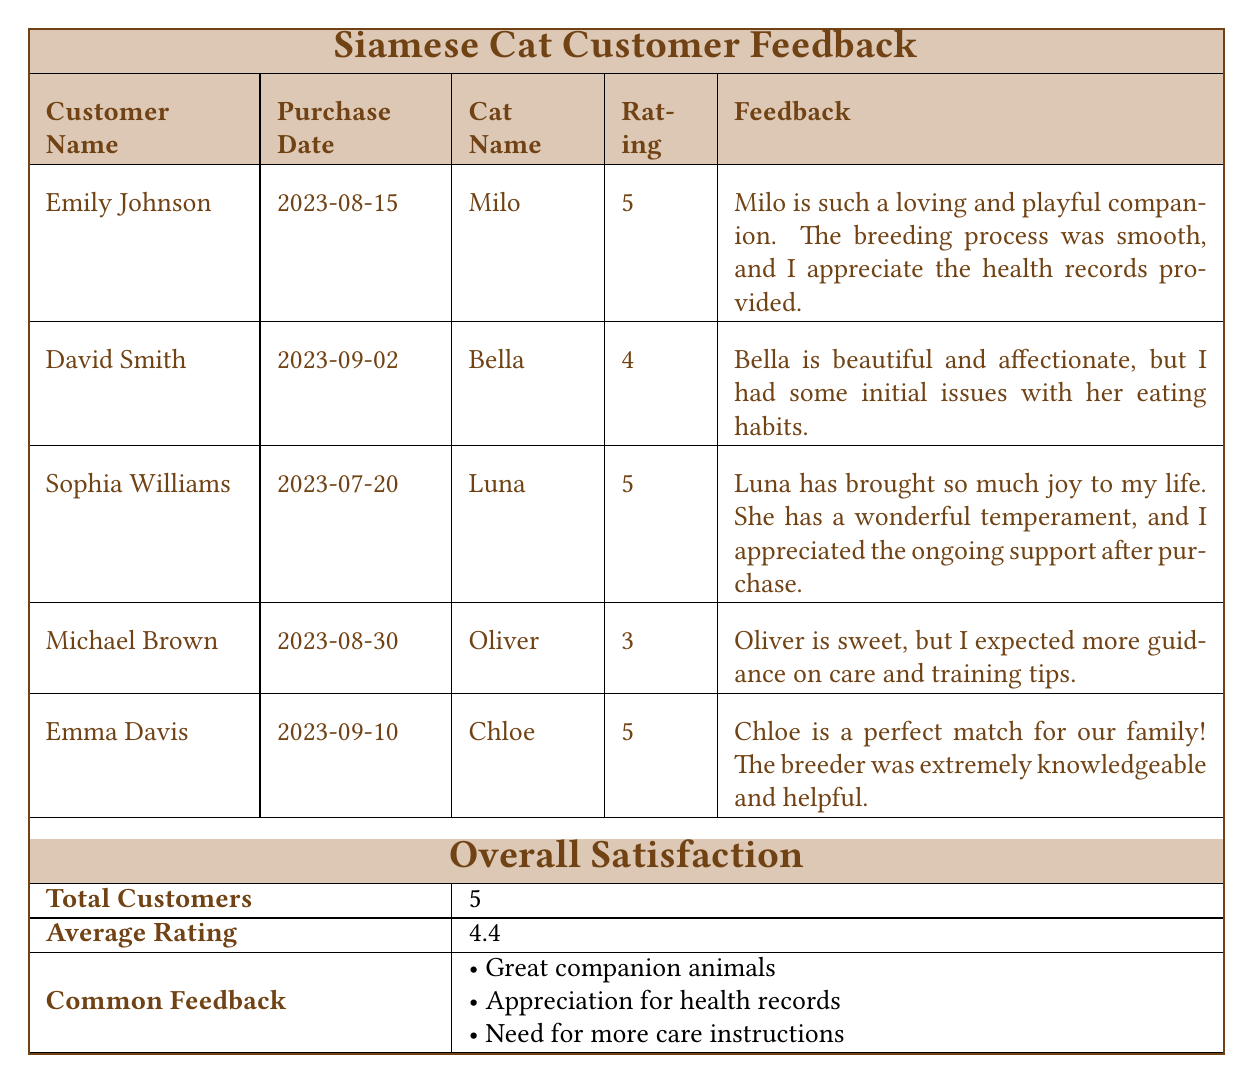What is the highest satisfaction rating recorded? The ratings listed for each customer are 5, 4, 5, 3, and 5. The highest rating among these is 5.
Answer: 5 Which customer provided feedback about initial eating issues? David Smith's feedback mentions having initial issues with Bella's eating habits.
Answer: David Smith How many customers gave a rating of 5? Counting the ratings, Emily Johnson, Sophia Williams, and Emma Davis each gave a rating of 5. That makes a total of 3 customers.
Answer: 3 What is the average satisfaction rating from the customers? To find the average rating: (5 + 4 + 5 + 3 + 5) = 22. Dividing by the number of customers (5), the average is 22/5 = 4.4.
Answer: 4.4 Did any customer express a need for more care instructions? Yes, Michael Brown's feedback indicated that he expected more guidance on care and training tips.
Answer: Yes What do most customers appreciate based on the common feedback? The common feedback lists "Appreciation for health records" as one of the points, which indicates that many customers value it.
Answer: Appreciation for health records What is the total number of customers who provided feedback? The table lists a total of 5 individual feedback entries, which is reflected in the overall satisfaction section as the total number of customers.
Answer: 5 Were there any customers who gave a rating of less than 4? Yes, Michael Brown gave a rating of 3, which is below 4.
Answer: Yes What feedback did Sophia Williams leave regarding her experience? She mentioned that Luna brought joy to her life, praised her temperament, and appreciated the ongoing support after the purchase.
Answer: She appreciated Luna's temperament and support 